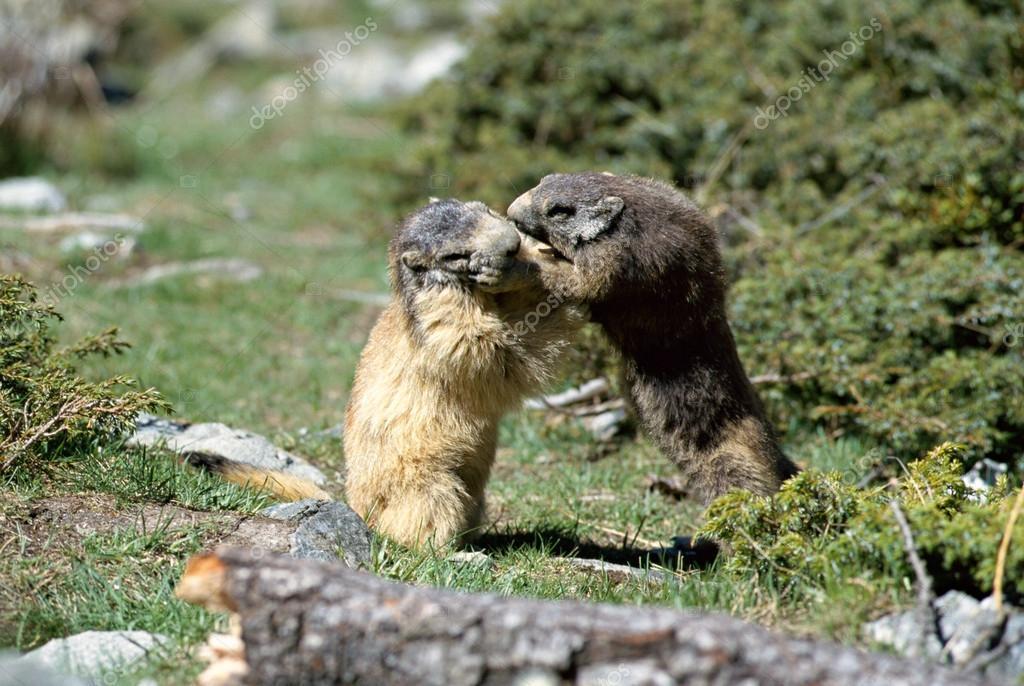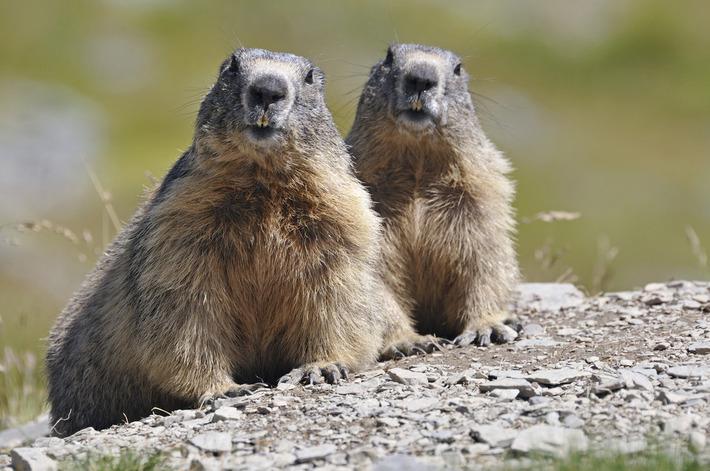The first image is the image on the left, the second image is the image on the right. Assess this claim about the two images: "In one of the images, there are two animals facing left.". Correct or not? Answer yes or no. No. The first image is the image on the left, the second image is the image on the right. Analyze the images presented: Is the assertion "An image shows two similarly-posed upright marmots, each facing leftward." valid? Answer yes or no. No. 